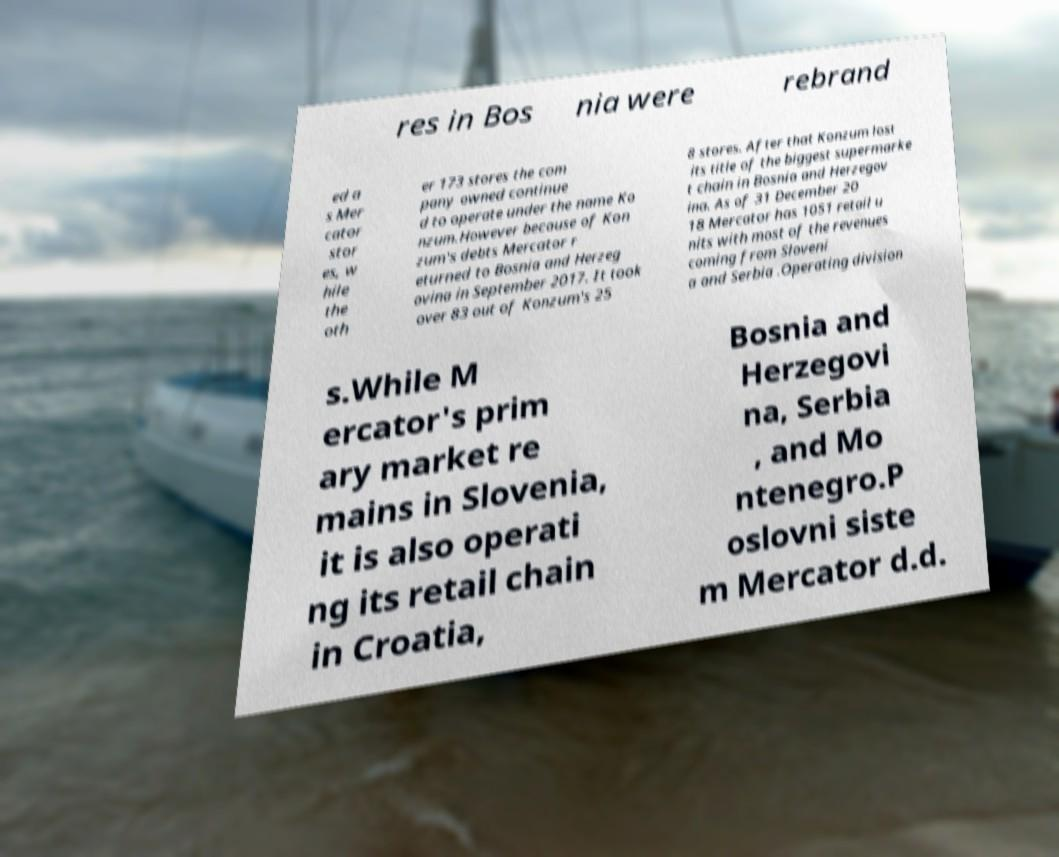Can you read and provide the text displayed in the image?This photo seems to have some interesting text. Can you extract and type it out for me? res in Bos nia were rebrand ed a s Mer cator stor es, w hile the oth er 173 stores the com pany owned continue d to operate under the name Ko nzum.However because of Kon zum's debts Mercator r eturned to Bosnia and Herzeg ovina in September 2017. It took over 83 out of Konzum's 25 8 stores. After that Konzum lost its title of the biggest supermarke t chain in Bosnia and Herzegov ina. As of 31 December 20 18 Mercator has 1051 retail u nits with most of the revenues coming from Sloveni a and Serbia .Operating division s.While M ercator's prim ary market re mains in Slovenia, it is also operati ng its retail chain in Croatia, Bosnia and Herzegovi na, Serbia , and Mo ntenegro.P oslovni siste m Mercator d.d. 